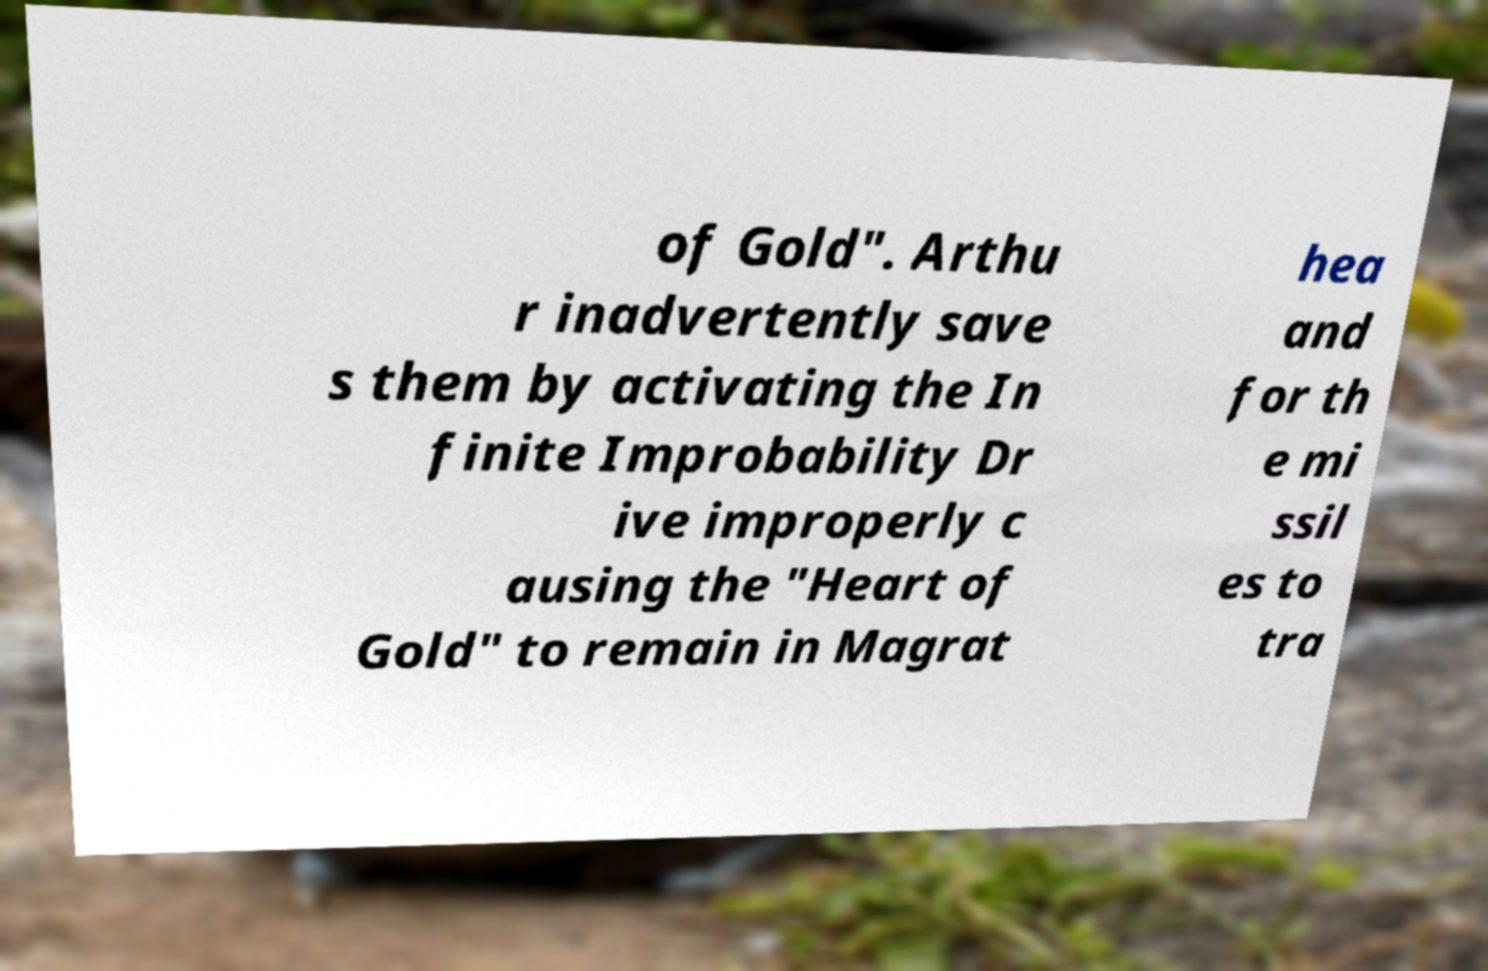Please read and relay the text visible in this image. What does it say? of Gold". Arthu r inadvertently save s them by activating the In finite Improbability Dr ive improperly c ausing the "Heart of Gold" to remain in Magrat hea and for th e mi ssil es to tra 